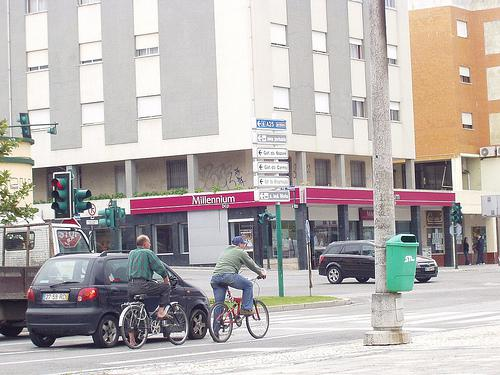Question: where is the picture taken?
Choices:
A. On the street.
B. In a department store.
C. In a house.
D. In a museum.
Answer with the letter. Answer: A Question: what color board?
Choices:
A. Brown.
B. Black.
C. White and blue.
D. Red.
Answer with the letter. Answer: C Question: where are the white lines?
Choices:
A. On the field.
B. On the corner.
C. On the sidewalk.
D. In the road.
Answer with the letter. Answer: D Question: how many traffic lights are seen?
Choices:
A. One.
B. Two.
C. Three.
D. Four.
Answer with the letter. Answer: B 